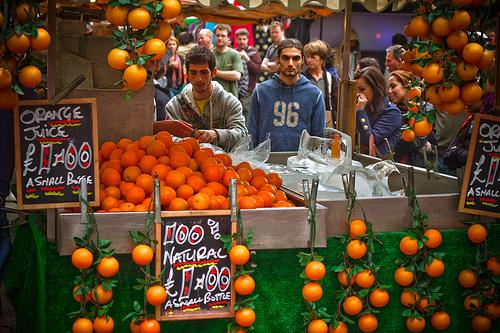Question: where is this picture taken?
Choices:
A. Fruit market.
B. Flee market.
C. Marathon.
D. Library.
Answer with the letter. Answer: A Question: what is being sold?
Choices:
A. Oranges.
B. Mangoes.
C. Tomatoes.
D. Apples.
Answer with the letter. Answer: A Question: what color are the oranges?
Choices:
A. Orange.
B. Green.
C. Brown.
D. Black.
Answer with the letter. Answer: A Question: who is in the picture?
Choices:
A. Men and women.
B. Children.
C. The MVP.
D. The valedictorian.
Answer with the letter. Answer: A Question: why are these people here?
Choices:
A. To sleep.
B. To look.
C. To shop.
D. To walk.
Answer with the letter. Answer: C 